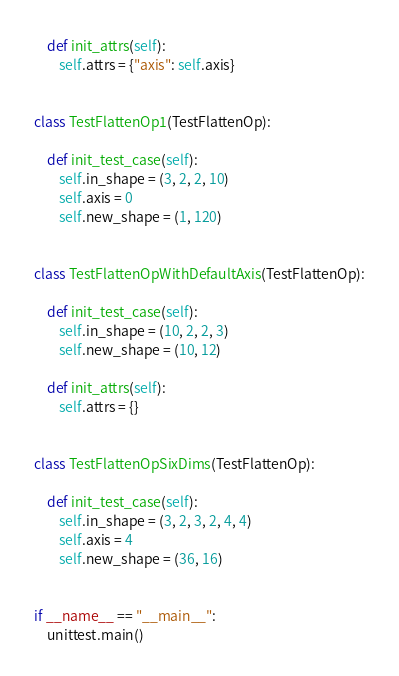<code> <loc_0><loc_0><loc_500><loc_500><_Python_>    def init_attrs(self):
        self.attrs = {"axis": self.axis}


class TestFlattenOp1(TestFlattenOp):

    def init_test_case(self):
        self.in_shape = (3, 2, 2, 10)
        self.axis = 0
        self.new_shape = (1, 120)


class TestFlattenOpWithDefaultAxis(TestFlattenOp):

    def init_test_case(self):
        self.in_shape = (10, 2, 2, 3)
        self.new_shape = (10, 12)

    def init_attrs(self):
        self.attrs = {}


class TestFlattenOpSixDims(TestFlattenOp):

    def init_test_case(self):
        self.in_shape = (3, 2, 3, 2, 4, 4)
        self.axis = 4
        self.new_shape = (36, 16)


if __name__ == "__main__":
    unittest.main()
</code> 